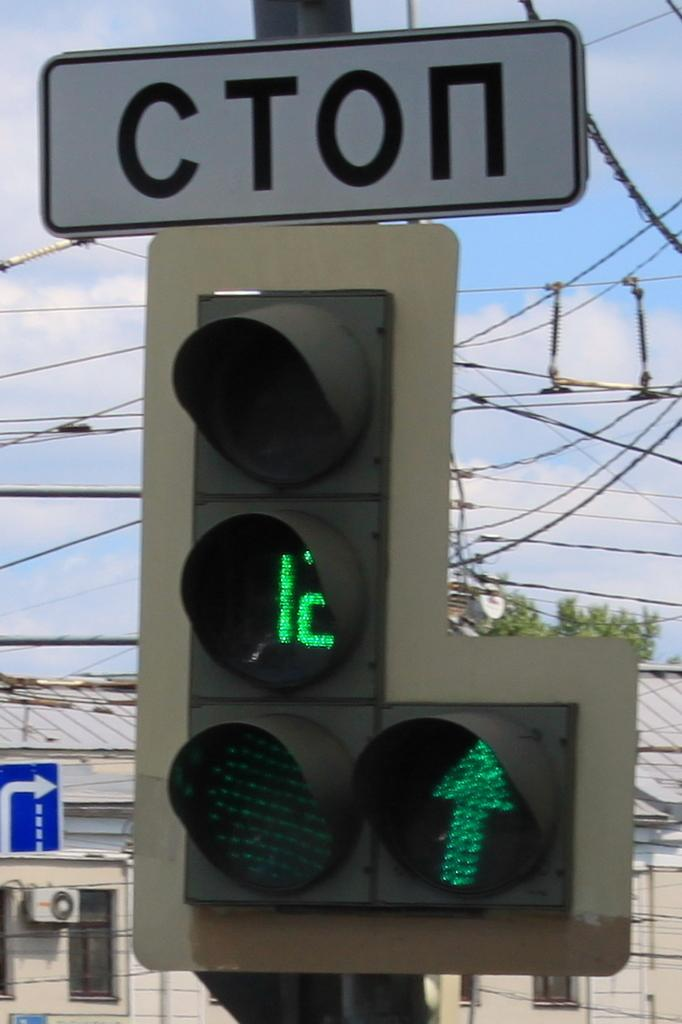Provide a one-sentence caption for the provided image. Cton traffic sign signal with twelve seconds left on the signal. 